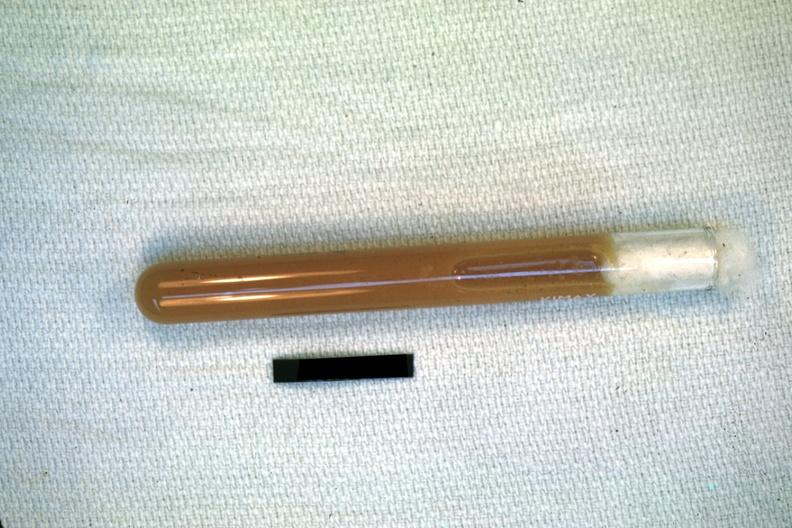does acute peritonitis illustrate pus from the peritoneal cavity?
Answer the question using a single word or phrase. No 